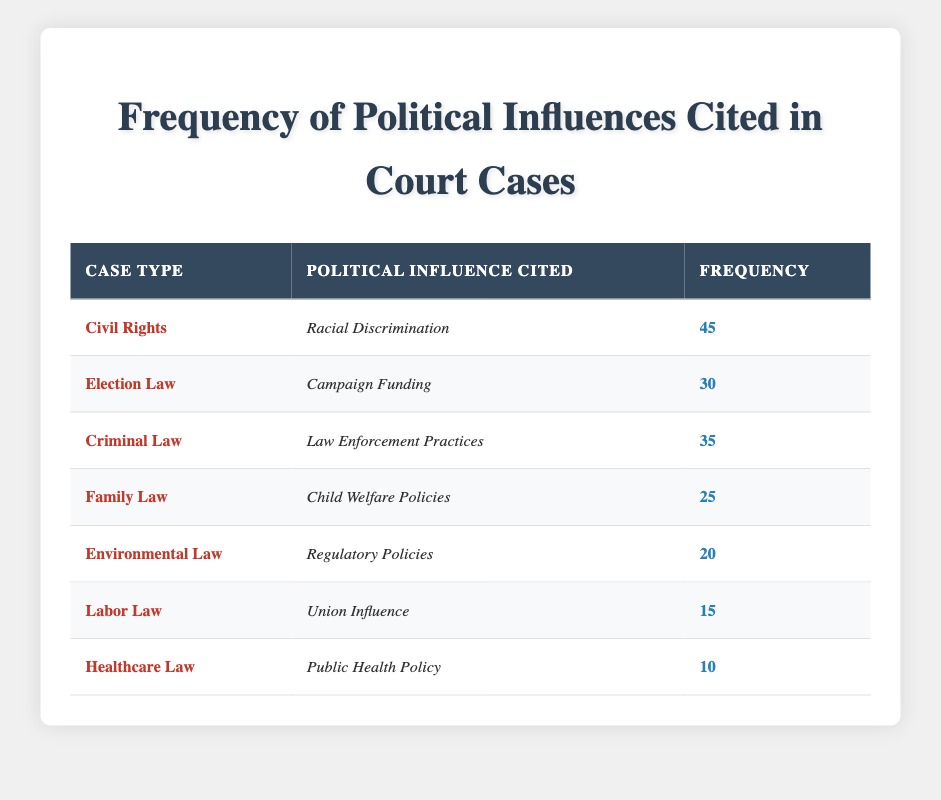What is the frequency of Racial Discrimination cited in Civil Rights cases? The table indicates that Racial Discrimination, as an influence in Civil Rights cases, has a frequency of 45.
Answer: 45 Which case type has the highest frequency of political influence cited? By examining the table, Civil Rights cases have the highest frequency with 45, compared to other case types.
Answer: Civil Rights Is the frequency of Union Influence greater than the frequency of Public Health Policy? The table shows Union Influence has a frequency of 15, while Public Health Policy has a frequency of 10. Since 15 is greater than 10, the statement is true.
Answer: Yes What is the total frequency of influences cited in Election Law and Criminal Law cases combined? For Election Law, the frequency is 30, and for Criminal Law, it is 35. Adding these gives 30 + 35 = 65.
Answer: 65 Which political influence was cited the least in the cases listed? The table shows that Public Health Policy, cited in Healthcare Law cases, has the lowest frequency of 10.
Answer: Public Health Policy What is the average frequency of political influences cited across all case types? To calculate the average, we first sum all frequencies: 45 + 30 + 35 + 25 + 20 + 15 + 10 = 180. Then, we divide by the number of case types, which is 7. Therefore, the average is 180 / 7 = approximately 25.71.
Answer: 25.71 Are there more cases citing Law Enforcement Practices than those citing Campaign Funding? The frequency for Law Enforcement Practices is 35, and for Campaign Funding, it's 30. Since 35 is greater than 30, the answer is true.
Answer: Yes Which influences cited in Family Law and Environmental Law cases have a combined frequency greater than 50? The frequency for Family Law is 25 and for Environmental Law is 20. Combined, they total 25 + 20 = 45, which is less than 50, so the answer is false.
Answer: No What is the difference in frequency between the most cited influence and the least cited influence? The most cited influence is Racial Discrimination with a frequency of 45, and the least cited influence is Public Health Policy with a frequency of 10. The difference is 45 - 10 = 35.
Answer: 35 